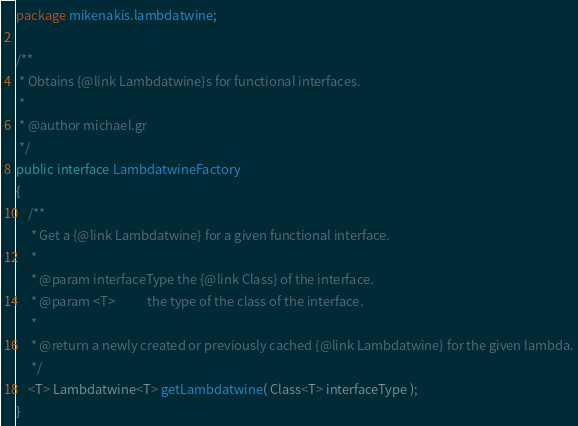<code> <loc_0><loc_0><loc_500><loc_500><_Java_>package mikenakis.lambdatwine;

/**
 * Obtains {@link Lambdatwine}s for functional interfaces.
 *
 * @author michael.gr
 */
public interface LambdatwineFactory
{
	/**
	 * Get a {@link Lambdatwine} for a given functional interface.
	 *
	 * @param interfaceType the {@link Class} of the interface.
	 * @param <T>           the type of the class of the interface.
	 *
	 * @return a newly created or previously cached {@link Lambdatwine} for the given lambda.
	 */
	<T> Lambdatwine<T> getLambdatwine( Class<T> interfaceType );
}
</code> 